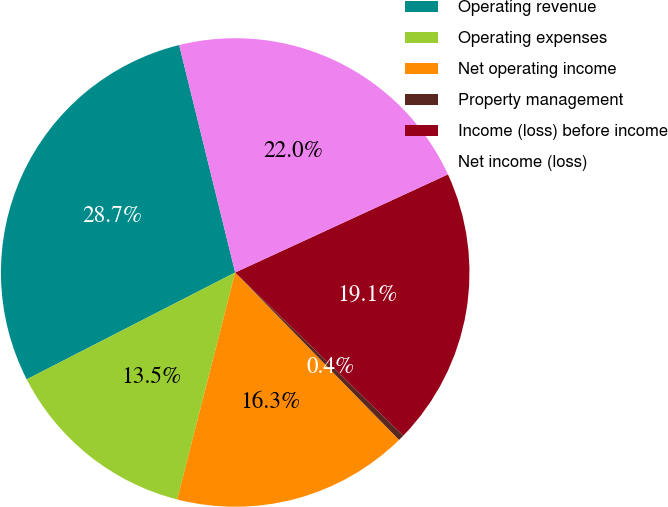<chart> <loc_0><loc_0><loc_500><loc_500><pie_chart><fcel>Operating revenue<fcel>Operating expenses<fcel>Net operating income<fcel>Property management<fcel>Income (loss) before income<fcel>Net income (loss)<nl><fcel>28.7%<fcel>13.48%<fcel>16.31%<fcel>0.41%<fcel>19.14%<fcel>21.97%<nl></chart> 